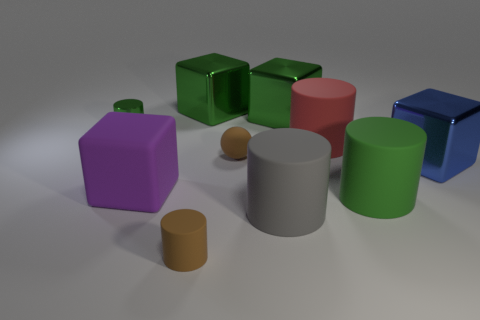Subtract all green spheres. How many green blocks are left? 2 Subtract all green metallic cylinders. How many cylinders are left? 4 Subtract all red cylinders. How many cylinders are left? 4 Subtract all spheres. How many objects are left? 9 Subtract all brown blocks. Subtract all red balls. How many blocks are left? 4 Add 5 gray rubber cylinders. How many gray rubber cylinders exist? 6 Subtract 0 cyan balls. How many objects are left? 10 Subtract all rubber cubes. Subtract all large matte cylinders. How many objects are left? 6 Add 8 large gray matte cylinders. How many large gray matte cylinders are left? 9 